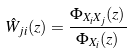Convert formula to latex. <formula><loc_0><loc_0><loc_500><loc_500>\hat { W } _ { j i } ( z ) = \frac { \Phi _ { X _ { i } X _ { j } } ( z ) } { \Phi _ { X _ { i } } ( z ) }</formula> 